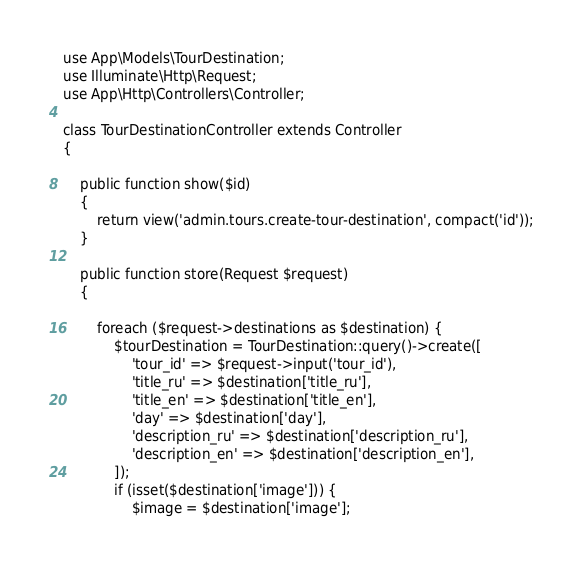<code> <loc_0><loc_0><loc_500><loc_500><_PHP_>
use App\Models\TourDestination;
use Illuminate\Http\Request;
use App\Http\Controllers\Controller;

class TourDestinationController extends Controller
{

    public function show($id)
    {
        return view('admin.tours.create-tour-destination', compact('id'));
    }

    public function store(Request $request)
    {

        foreach ($request->destinations as $destination) {
            $tourDestination = TourDestination::query()->create([
                'tour_id' => $request->input('tour_id'),
                'title_ru' => $destination['title_ru'],
                'title_en' => $destination['title_en'],
                'day' => $destination['day'],
                'description_ru' => $destination['description_ru'],
                'description_en' => $destination['description_en'],
            ]);
            if (isset($destination['image'])) {
                $image = $destination['image'];</code> 